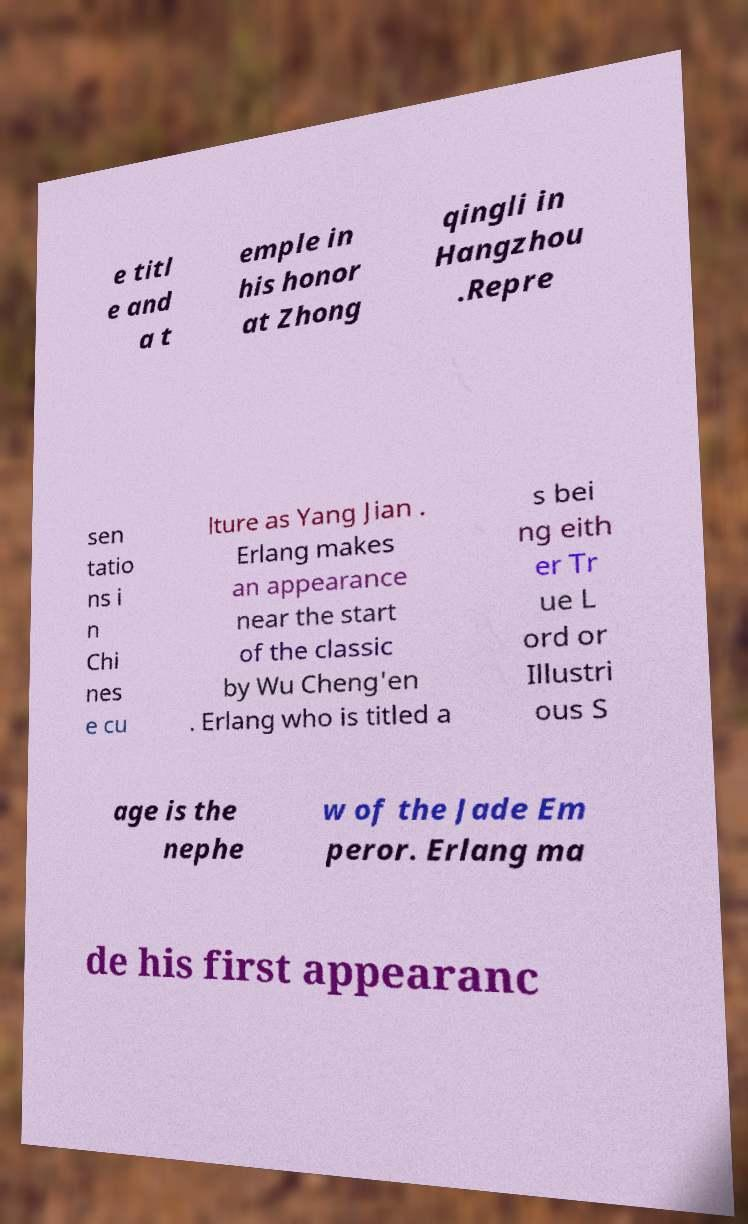Could you assist in decoding the text presented in this image and type it out clearly? e titl e and a t emple in his honor at Zhong qingli in Hangzhou .Repre sen tatio ns i n Chi nes e cu lture as Yang Jian . Erlang makes an appearance near the start of the classic by Wu Cheng'en . Erlang who is titled a s bei ng eith er Tr ue L ord or Illustri ous S age is the nephe w of the Jade Em peror. Erlang ma de his first appearanc 